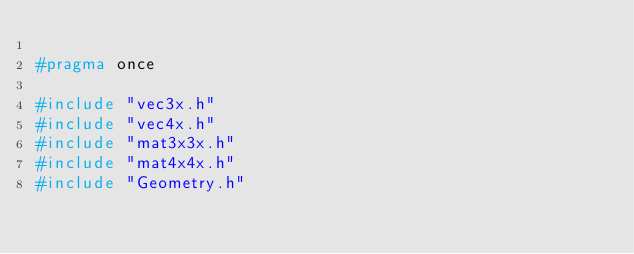Convert code to text. <code><loc_0><loc_0><loc_500><loc_500><_C_>
#pragma once

#include "vec3x.h"
#include "vec4x.h"
#include "mat3x3x.h"
#include "mat4x4x.h"
#include "Geometry.h"
</code> 